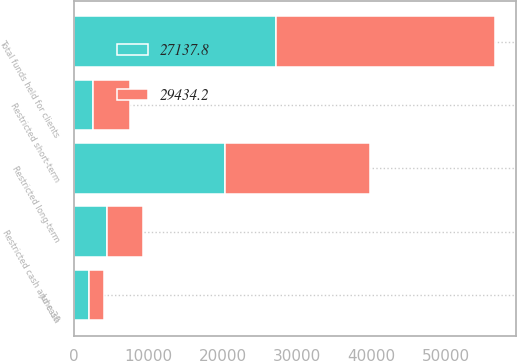Convert chart. <chart><loc_0><loc_0><loc_500><loc_500><stacked_bar_chart><ecel><fcel>June 30<fcel>Restricted cash and cash<fcel>Restricted short-term<fcel>Restricted long-term<fcel>Total funds held for clients<nl><fcel>29434.2<fcel>2019<fcel>4847<fcel>5013.9<fcel>19573.3<fcel>29434.2<nl><fcel>27137.8<fcel>2018<fcel>4372.1<fcel>2521.4<fcel>20244.3<fcel>27137.8<nl></chart> 